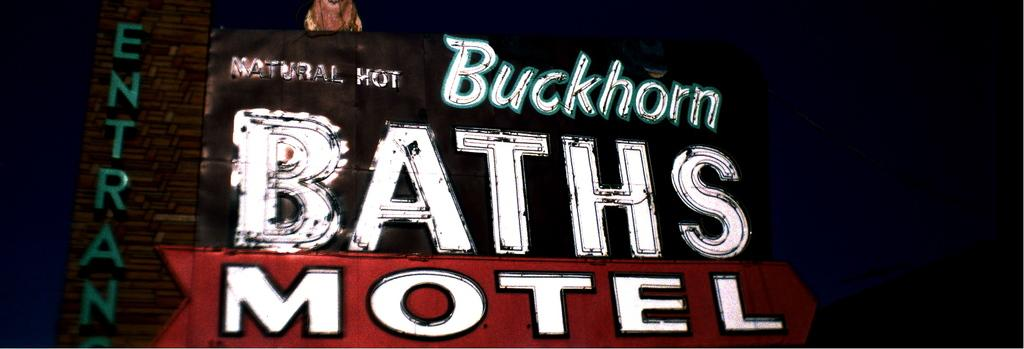<image>
Describe the image concisely. Sign to the Baths Motel with the word ENTRANCE in green. 